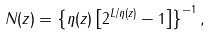Convert formula to latex. <formula><loc_0><loc_0><loc_500><loc_500>N ( z ) = \left \{ \eta ( z ) \left [ 2 ^ { L / \eta ( z ) } - 1 \right ] \right \} ^ { - 1 } ,</formula> 